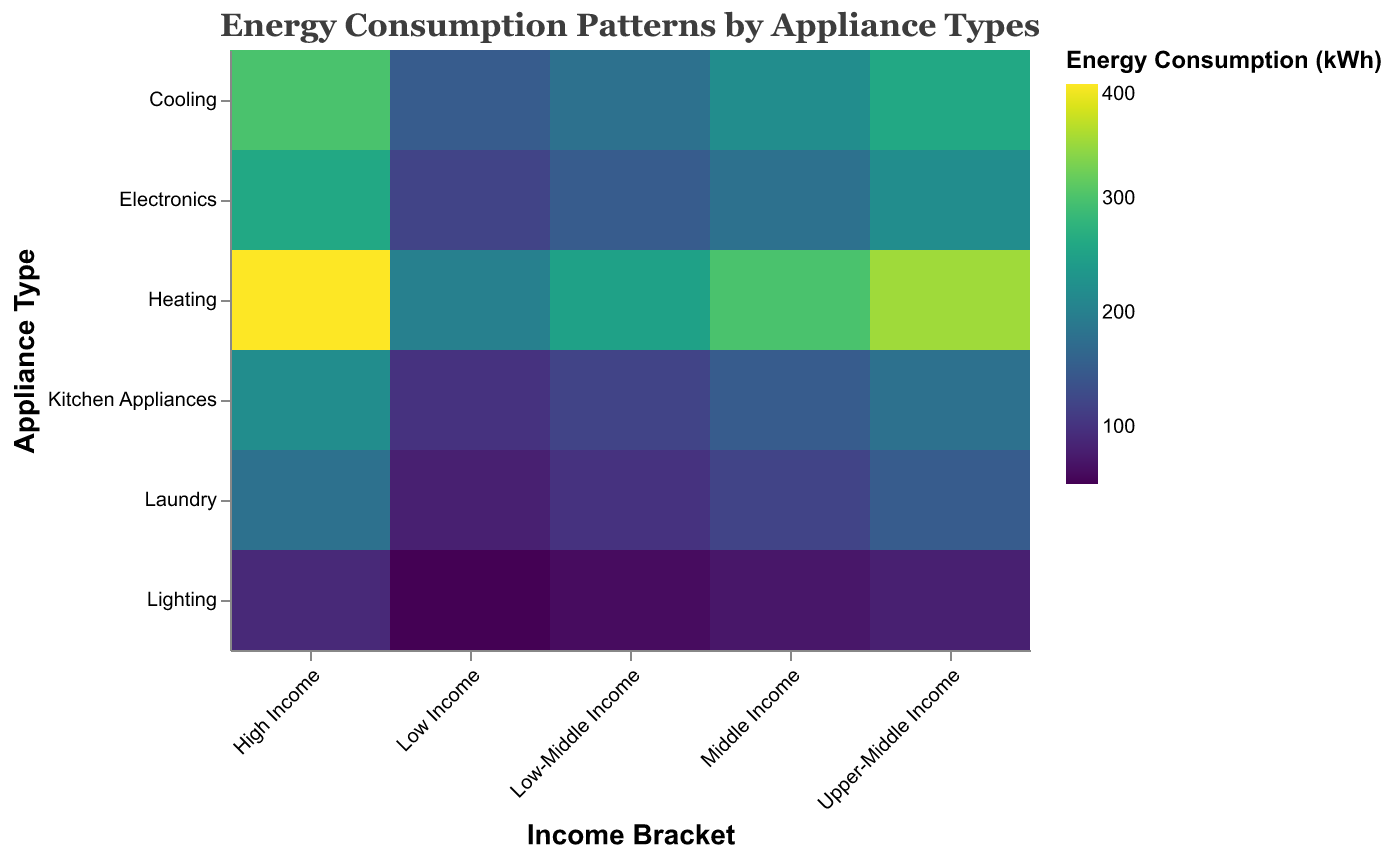What is the title of the plot? The title is located at the top of the heatmap. By reading it directly, one can identify that it is "Energy Consumption Patterns by Appliance Types"
Answer: Energy Consumption Patterns by Appliance Types Which income bracket has the highest energy consumption for heating? Look for the darkest color in the 'Heating' row. The darkest color appears in the 'High Income' column, indicating the highest consumption.
Answer: High Income Which appliance type shows the least energy consumption for the 'Low Income' bracket? Check the 'Low Income' column for the lightest color and find it in the 'Laundry' row.
Answer: Laundry How does the energy consumption for electronics in the 'Upper-Middle Income' bracket compare to the 'Low-Middle Income' bracket? Compare the color intensity for electronics in both income brackets. The 'Upper-Middle Income' has a darker color, indicating higher consumption.
Answer: Higher in Upper-Middle Income What is the total energy consumption for kitchen appliances across all income brackets? Sum the values for kitchen appliances in each income bracket: 100 (Low Income) + 120 (Low-Middle Income) + 150 (Middle Income) + 180 (Upper-Middle Income) + 220 (High Income).
Answer: 770 kWh Which income bracket shows the most balanced energy consumption across all appliance types? Look for the column where colors are most consistent. 'Middle Income' bracket has relatively uniform color intensity across all appliances.
Answer: Middle Income How much more energy is consumed by lighting in the 'High Income' bracket compared to the 'Low Income' bracket? Subtract the consumption for 'Low Income' (50 kWh) from 'High Income' (90 kWh).
Answer: 40 kWh Which appliance type has the highest variation in energy consumption across different income brackets? Look horizontally across each appliance type and assess which row shows the greatest range of color intensity. 'Heating' shows the highest variation from light to dark.
Answer: Heating What is the average energy consumption for cooling in the 'Middle Income' and 'Upper-Middle Income' brackets? Average the cooling kWh values for 'Middle Income' (220) and 'Upper-Middle Income' (260): (220 + 260) / 2.
Answer: 240 kWh 